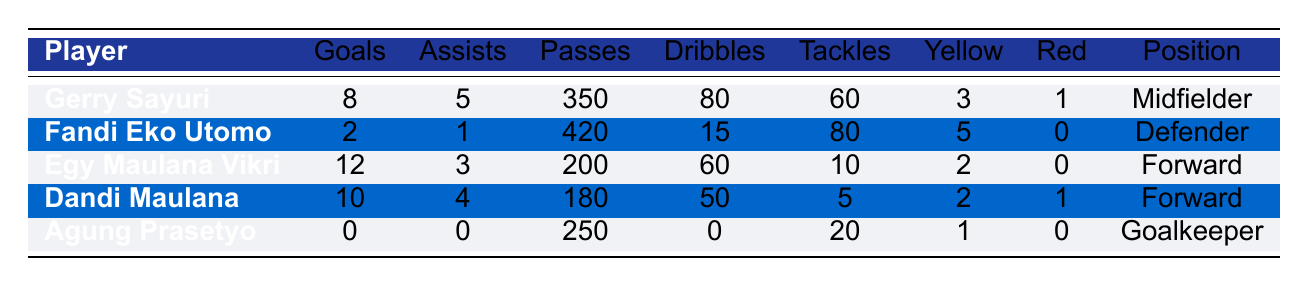What is the total number of goals scored by PSIS Semarang's players? To find the total number of goals, we need to add the goals scored by each player: 8 (Gerry Sayuri) + 2 (Fandi Eko Utomo) + 12 (Egy Maulana Vikri) + 10 (Dandi Maulana) + 0 (Agung Prasetyo) = 32
Answer: 32 Who has the highest number of assists among the players? By looking at the assists column, we see that Gerry Sayuri has 5 assists, which is higher than the others: 1 (Fandi Eko Utomo), 3 (Egy Maulana Vikri), 4 (Dandi Maulana), and 0 (Agung Prasetyo). Therefore, Gerry Sayuri has the highest assists.
Answer: Gerry Sayuri Did any player receive a red card? By checking the red cards column, we see that both Gerry Sayuri and Dandi Maulana received 1 red card while the other players did not receive any. Thus, the answer is yes.
Answer: Yes What is the average number of tackles made by the players? To find the average tackles, we add up the tackles: 60 (Gerry Sayuri) + 80 (Fandi Eko Utomo) + 10 (Egy Maulana Vikri) + 5 (Dandi Maulana) + 20 (Agung Prasetyo) = 175. Then, we divide this by the number of players (5): 175 / 5 = 35.
Answer: 35 Which player completed the most passes? Looking at the passes_completed column, Fandi Eko Utomo completed 420 passes, which is higher than the others: 350 (Gerry Sayuri), 200 (Egy Maulana Vikri), 180 (Dandi Maulana), and 250 (Agung Prasetyo).
Answer: Fandi Eko Utomo 